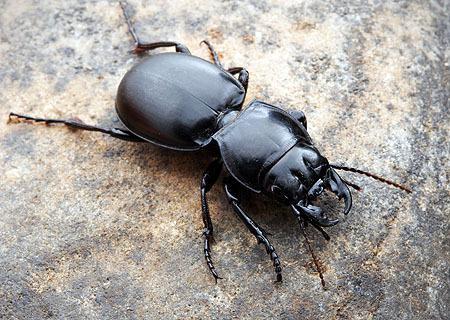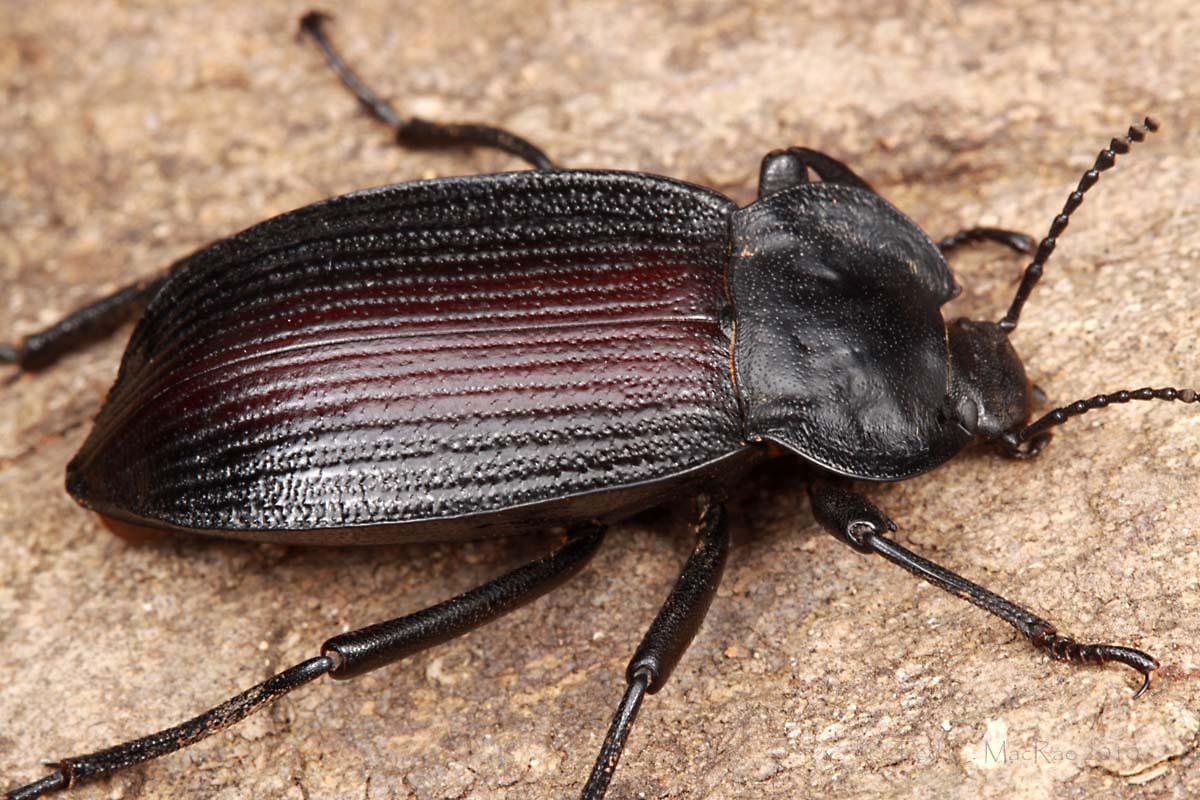The first image is the image on the left, the second image is the image on the right. Given the left and right images, does the statement "One image shows a beetle but no ball, and the other image shows a beetle partly perched on a ball." hold true? Answer yes or no. No. The first image is the image on the left, the second image is the image on the right. Examine the images to the left and right. Is the description "There is only one dungball in the image pair." accurate? Answer yes or no. No. 